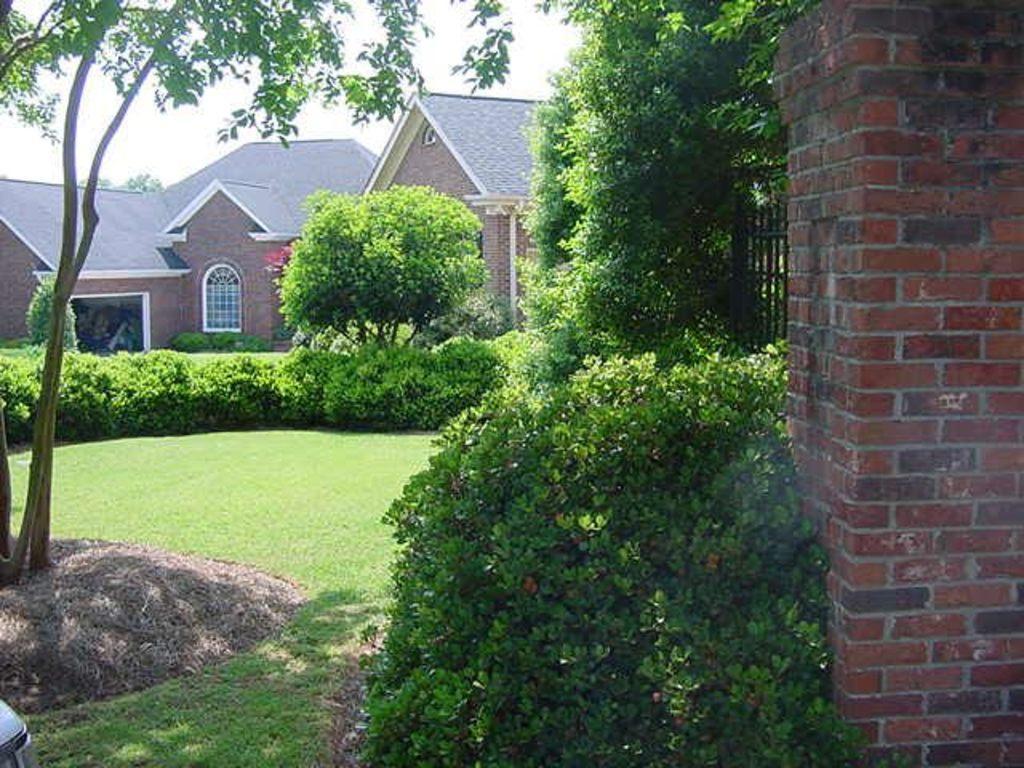Could you give a brief overview of what you see in this image? In the right side it's a brick wall, these are the plants in the middle. In the long back side there are houses, in the left side there are trees. 